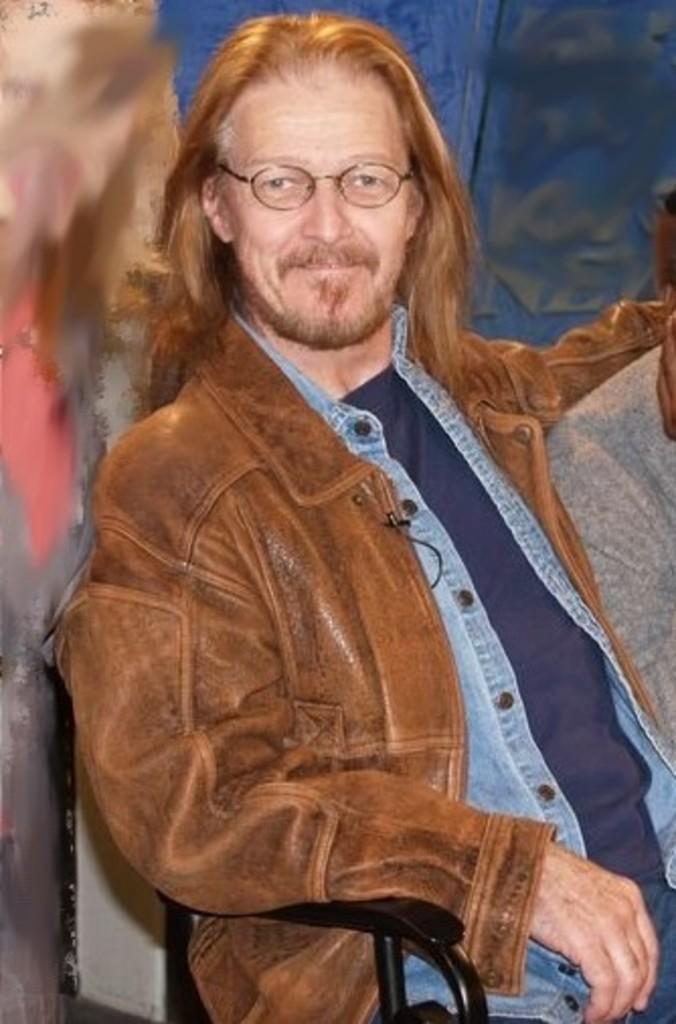Please provide a concise description of this image. In this image we can see a person sitting on the chair. 